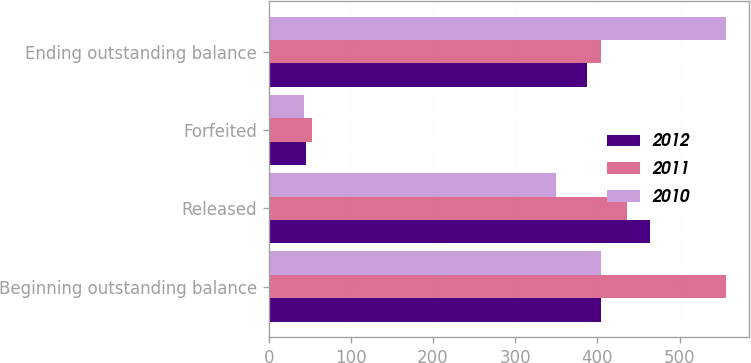Convert chart. <chart><loc_0><loc_0><loc_500><loc_500><stacked_bar_chart><ecel><fcel>Beginning outstanding balance<fcel>Released<fcel>Forfeited<fcel>Ending outstanding balance<nl><fcel>2012<fcel>405<fcel>464<fcel>45<fcel>388<nl><fcel>2011<fcel>557<fcel>436<fcel>53<fcel>405<nl><fcel>2010<fcel>405<fcel>350<fcel>43<fcel>557<nl></chart> 